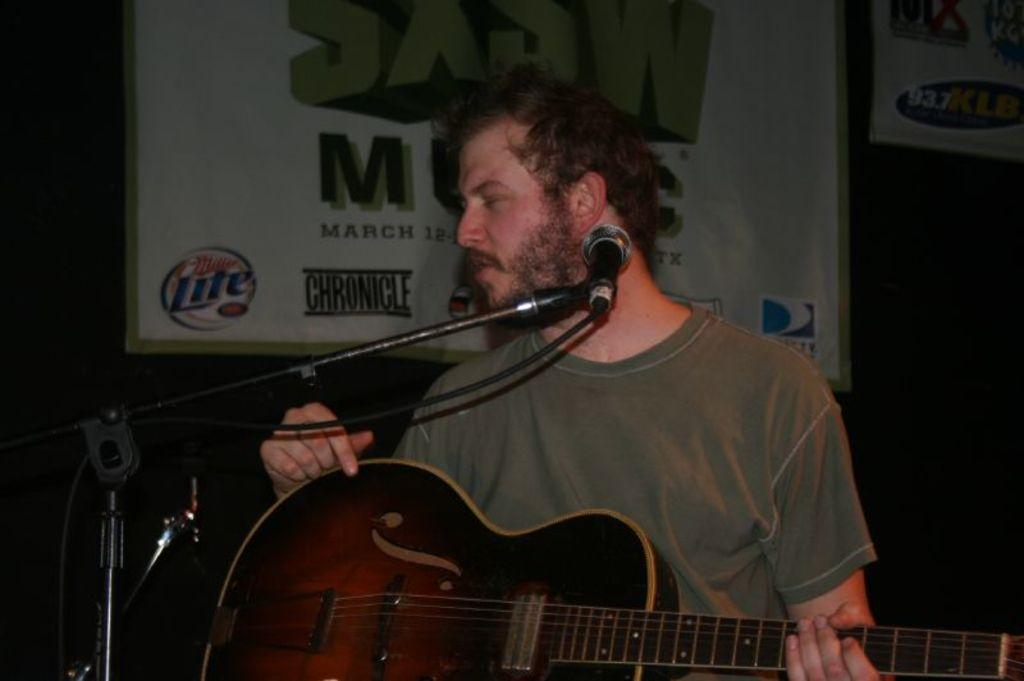Who is present in the image? There is a man in the image. What is the man doing in the image? The man is standing in the image. What object is the man holding in his hand? The man is holding a guitar in his hand. What is in front of the man? There is a microphone in front of the man. What can be seen in the background of the image? There is a hoarding visible behind the man. How many trucks can be seen in the image? There are no trucks visible in the image. 